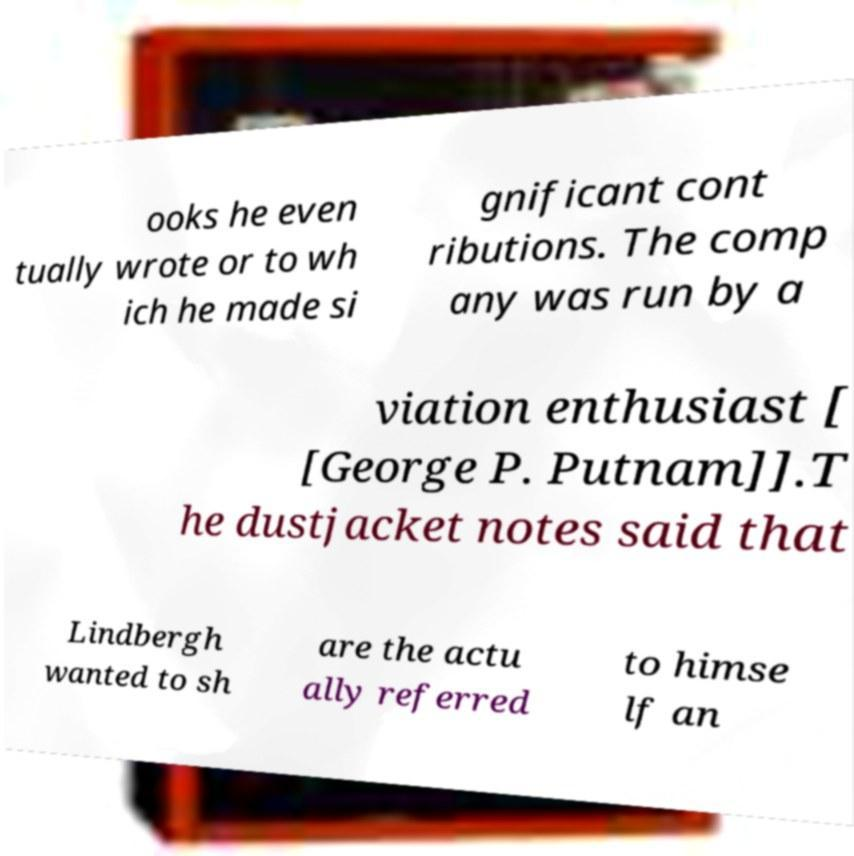Can you read and provide the text displayed in the image?This photo seems to have some interesting text. Can you extract and type it out for me? ooks he even tually wrote or to wh ich he made si gnificant cont ributions. The comp any was run by a viation enthusiast [ [George P. Putnam]].T he dustjacket notes said that Lindbergh wanted to sh are the actu ally referred to himse lf an 